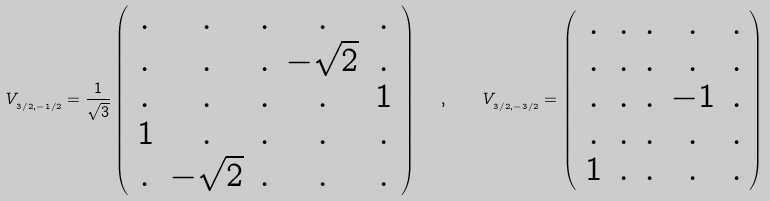Convert formula to latex. <formula><loc_0><loc_0><loc_500><loc_500>V _ { _ { 3 / 2 , - 1 / 2 } } = \frac { 1 } { \sqrt { 3 } } \left ( \begin{array} { c c c c c } . & . & . & . & . \\ . & . & . & - \sqrt { 2 } & . \\ . & . & . & . & 1 \\ 1 & . & . & . & . \\ . & - \sqrt { 2 } & . & . & . \end{array} \right ) \ \ , \quad V _ { _ { 3 / 2 , - 3 / 2 } } = \left ( \begin{array} { c c c c c } . & . & . & . & . \\ . & . & . & . & . \\ . & . & . & - 1 & . \\ . & . & . & . & . \\ 1 & . & . & . & . \end{array} \right )</formula> 